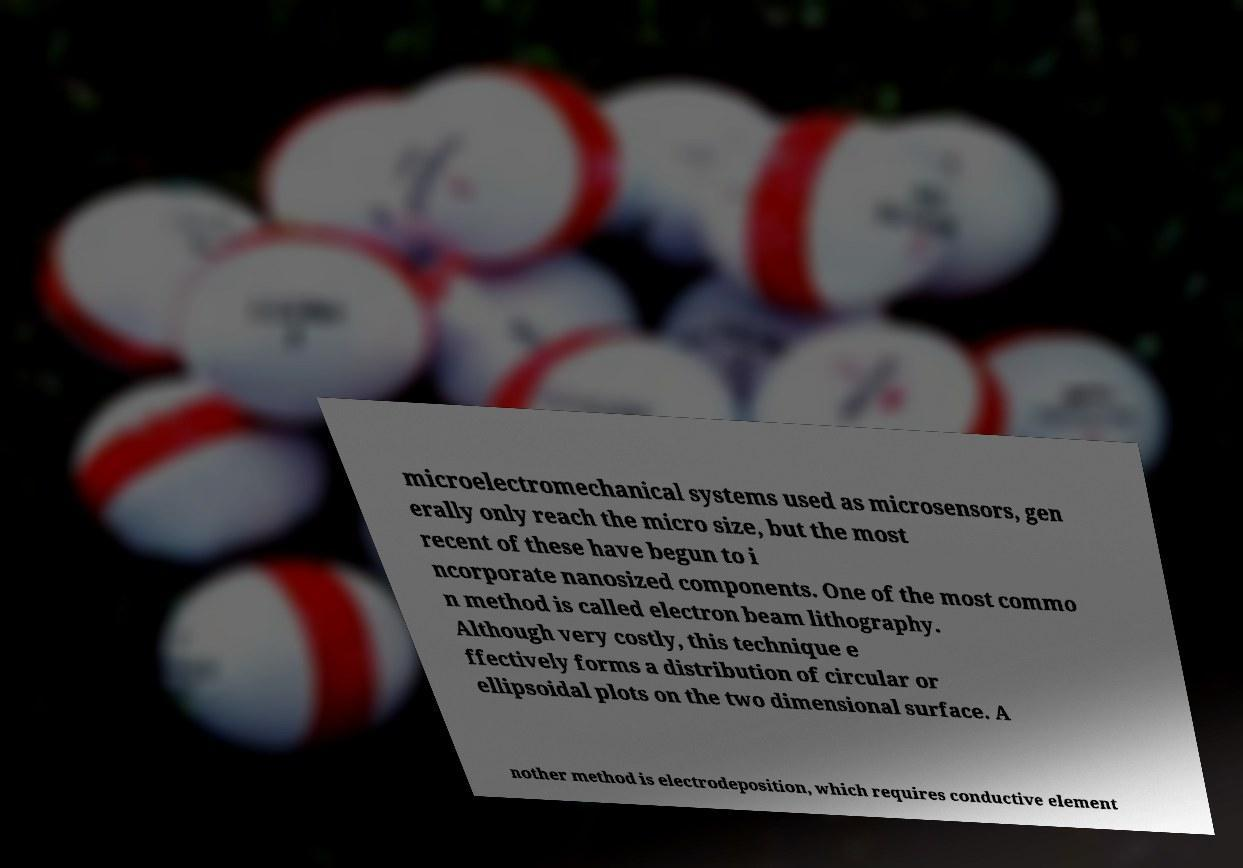For documentation purposes, I need the text within this image transcribed. Could you provide that? microelectromechanical systems used as microsensors, gen erally only reach the micro size, but the most recent of these have begun to i ncorporate nanosized components. One of the most commo n method is called electron beam lithography. Although very costly, this technique e ffectively forms a distribution of circular or ellipsoidal plots on the two dimensional surface. A nother method is electrodeposition, which requires conductive element 